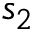<formula> <loc_0><loc_0><loc_500><loc_500>s _ { 2 }</formula> 